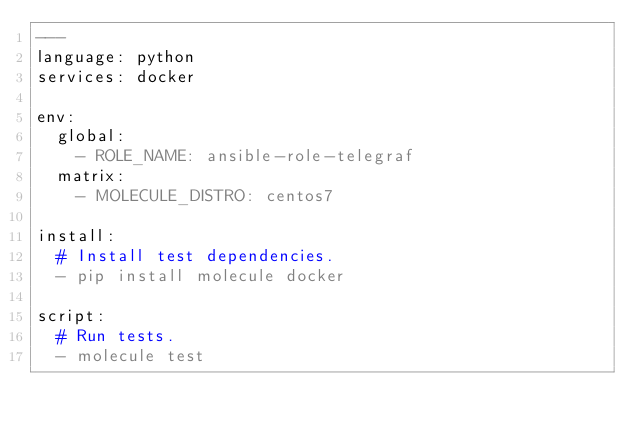Convert code to text. <code><loc_0><loc_0><loc_500><loc_500><_YAML_>---
language: python
services: docker

env:
  global:
    - ROLE_NAME: ansible-role-telegraf
  matrix:
    - MOLECULE_DISTRO: centos7

install:
  # Install test dependencies.
  - pip install molecule docker

script:
  # Run tests.
  - molecule test
</code> 